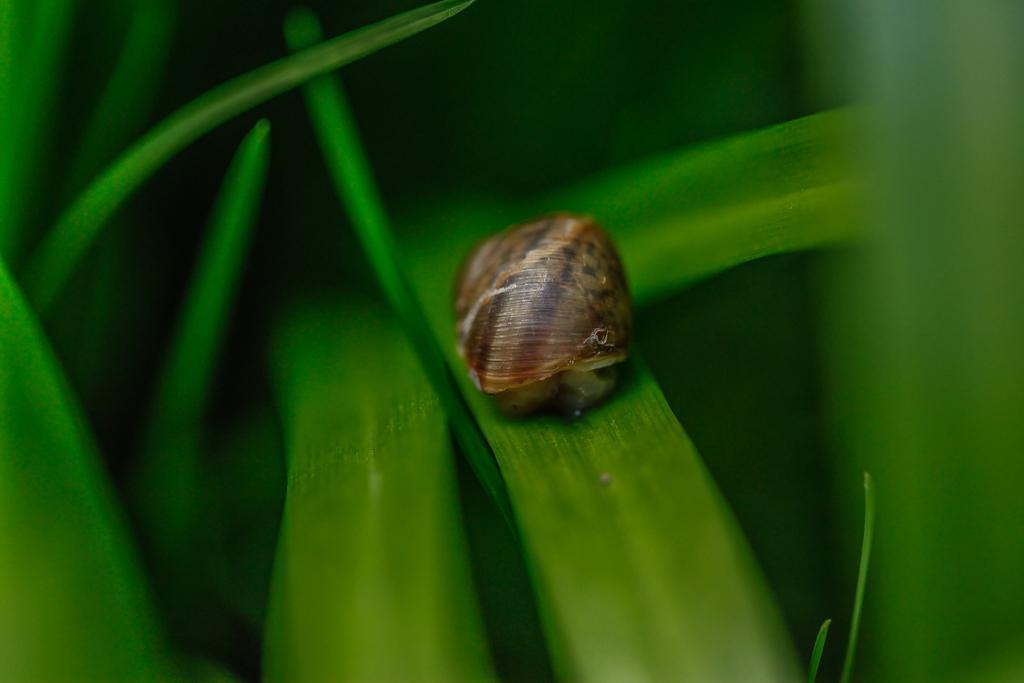Describe this image in one or two sentences. In the foreground of the picture, there is a snail on a leaf. Around it we can see few leaves. 